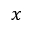Convert formula to latex. <formula><loc_0><loc_0><loc_500><loc_500>x</formula> 